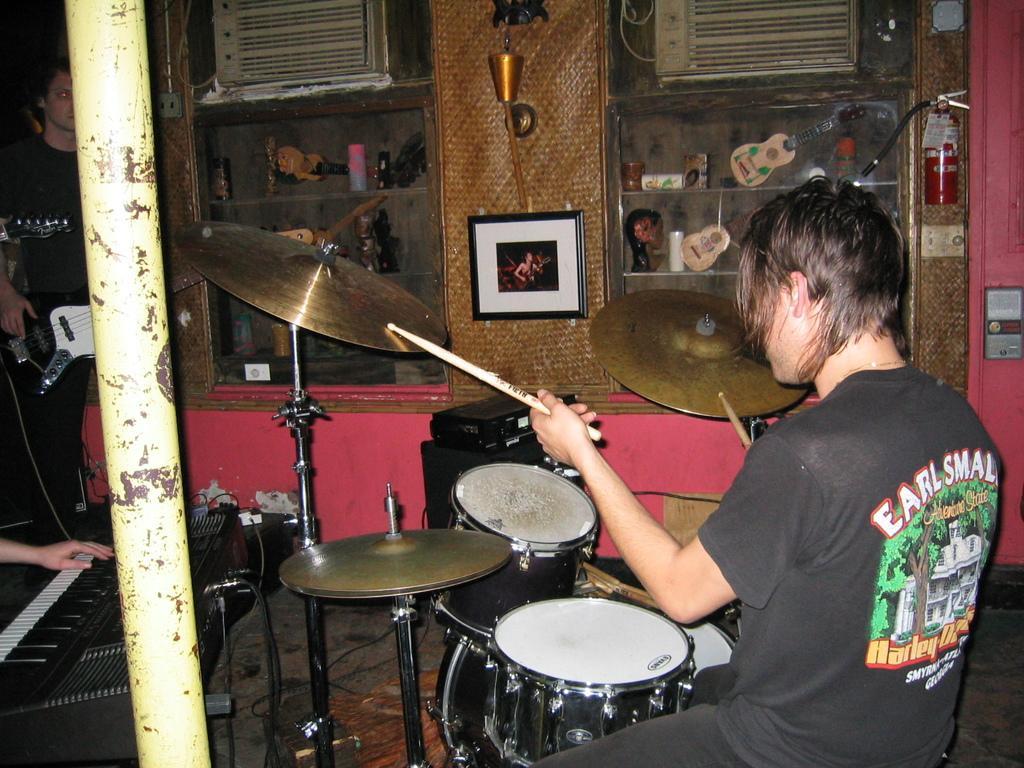In one or two sentences, can you explain what this image depicts? This picture seems to be clicked inside the room. On the right we can see a person wearing black color dress, sitting and holding drumsticks and seems to be playing cymbals and drums. On the left we can see the hand of a person seems to be playing piano and we can see a person wearing a black color dress standing and seems to be playing guitar and we can see a metal rod and some objects are placed on the ground. In the background we can see a fire extinguisher, picture frame hanging on the wall and we can see the shelves containing some show pieces of guitars and many other objects. At the top we can see some other objects. 